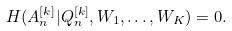Convert formula to latex. <formula><loc_0><loc_0><loc_500><loc_500>H ( A _ { n } ^ { [ k ] } | Q _ { n } ^ { [ k ] } , W _ { 1 } , \dots , W _ { K } ) = 0 .</formula> 